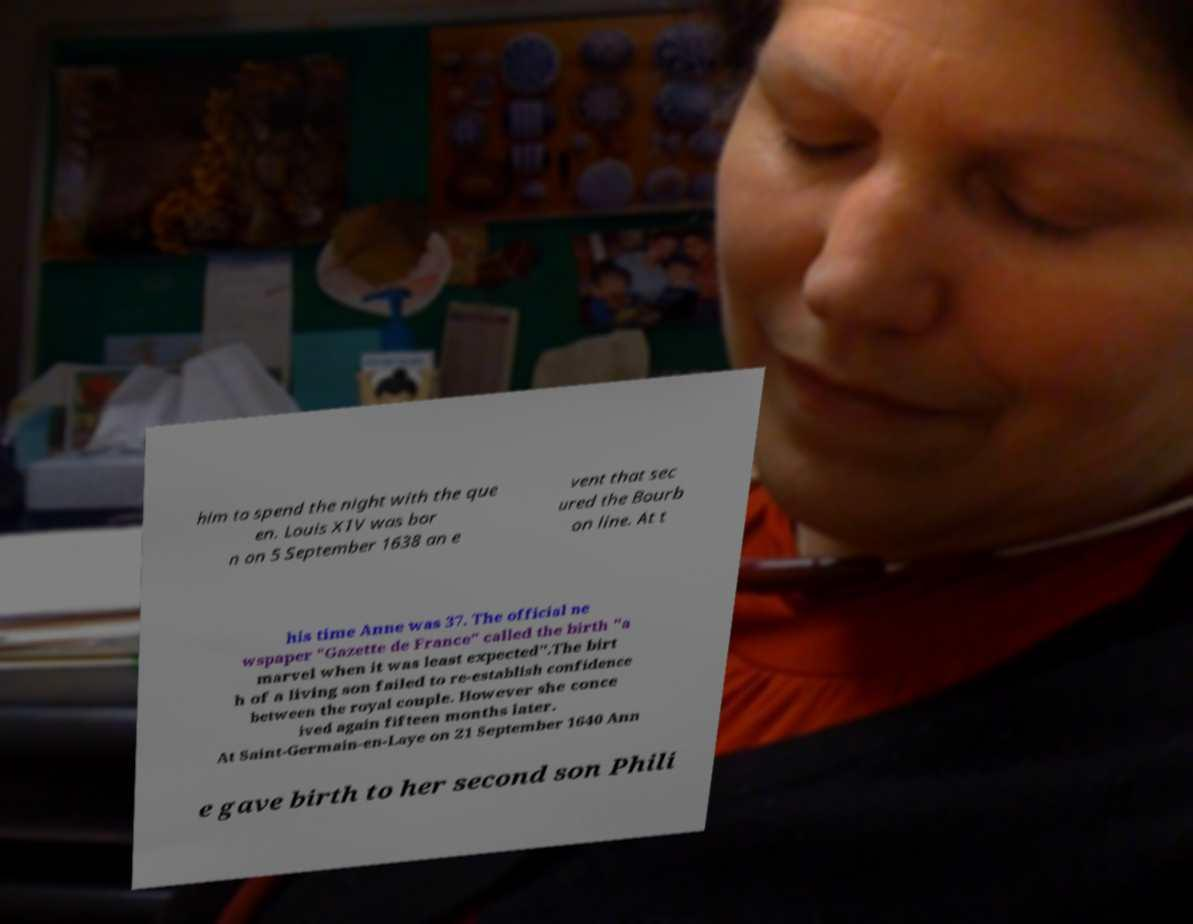There's text embedded in this image that I need extracted. Can you transcribe it verbatim? him to spend the night with the que en. Louis XIV was bor n on 5 September 1638 an e vent that sec ured the Bourb on line. At t his time Anne was 37. The official ne wspaper "Gazette de France" called the birth "a marvel when it was least expected".The birt h of a living son failed to re-establish confidence between the royal couple. However she conce ived again fifteen months later. At Saint-Germain-en-Laye on 21 September 1640 Ann e gave birth to her second son Phili 